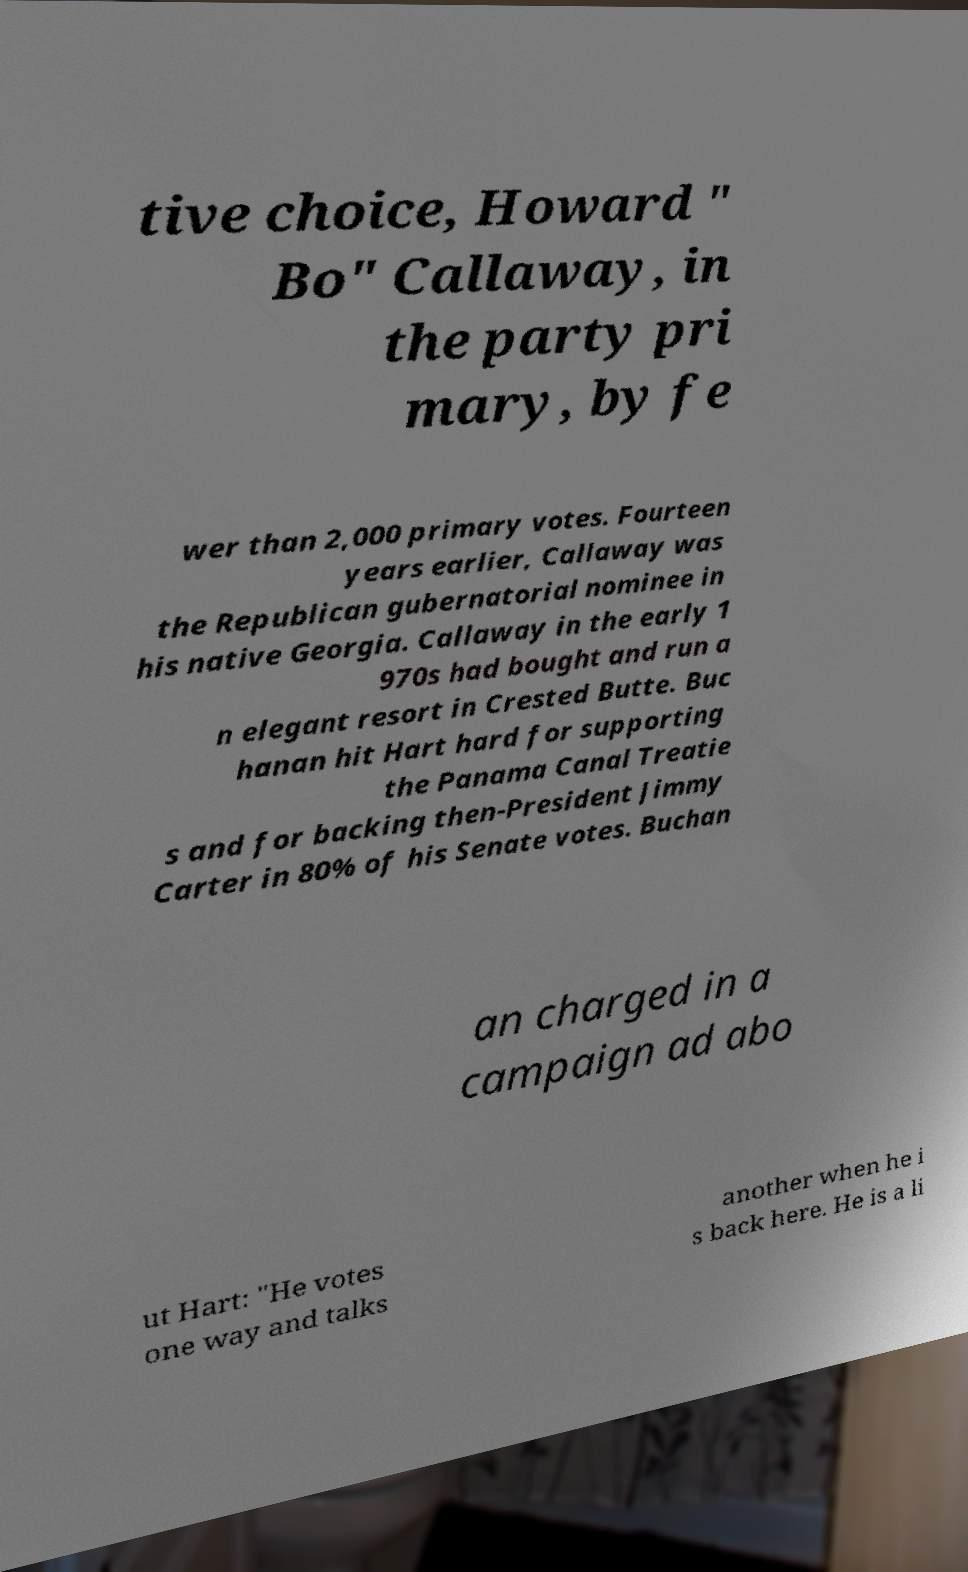For documentation purposes, I need the text within this image transcribed. Could you provide that? tive choice, Howard " Bo" Callaway, in the party pri mary, by fe wer than 2,000 primary votes. Fourteen years earlier, Callaway was the Republican gubernatorial nominee in his native Georgia. Callaway in the early 1 970s had bought and run a n elegant resort in Crested Butte. Buc hanan hit Hart hard for supporting the Panama Canal Treatie s and for backing then-President Jimmy Carter in 80% of his Senate votes. Buchan an charged in a campaign ad abo ut Hart: "He votes one way and talks another when he i s back here. He is a li 